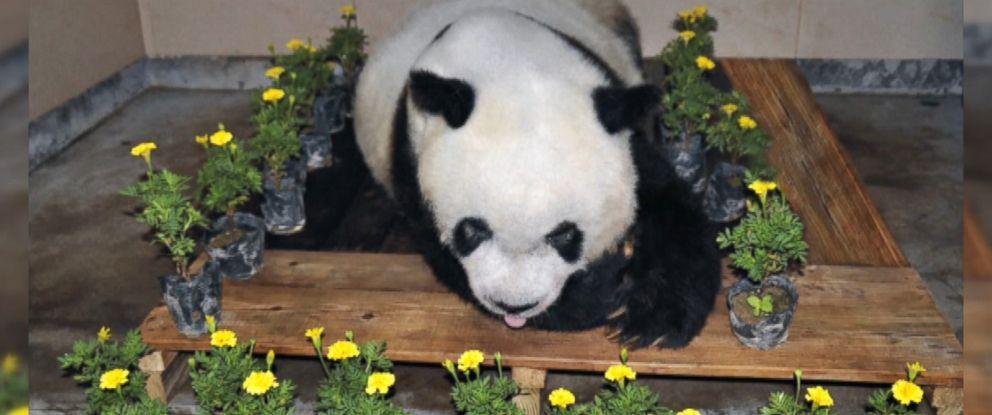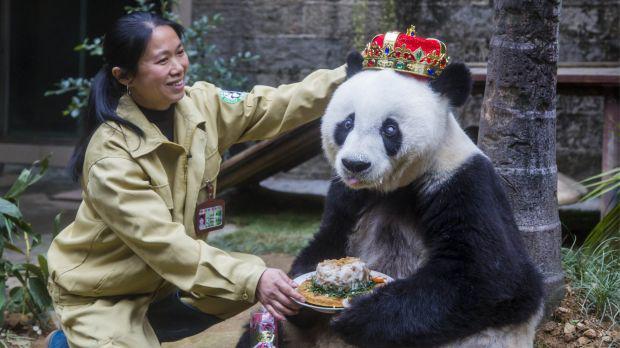The first image is the image on the left, the second image is the image on the right. Examine the images to the left and right. Is the description "The combined images include a dark-haired woman and a panda wearing a red-and-gold crown." accurate? Answer yes or no. Yes. The first image is the image on the left, the second image is the image on the right. Examine the images to the left and right. Is the description "The panda in the image on the right is wearing a hat." accurate? Answer yes or no. Yes. 